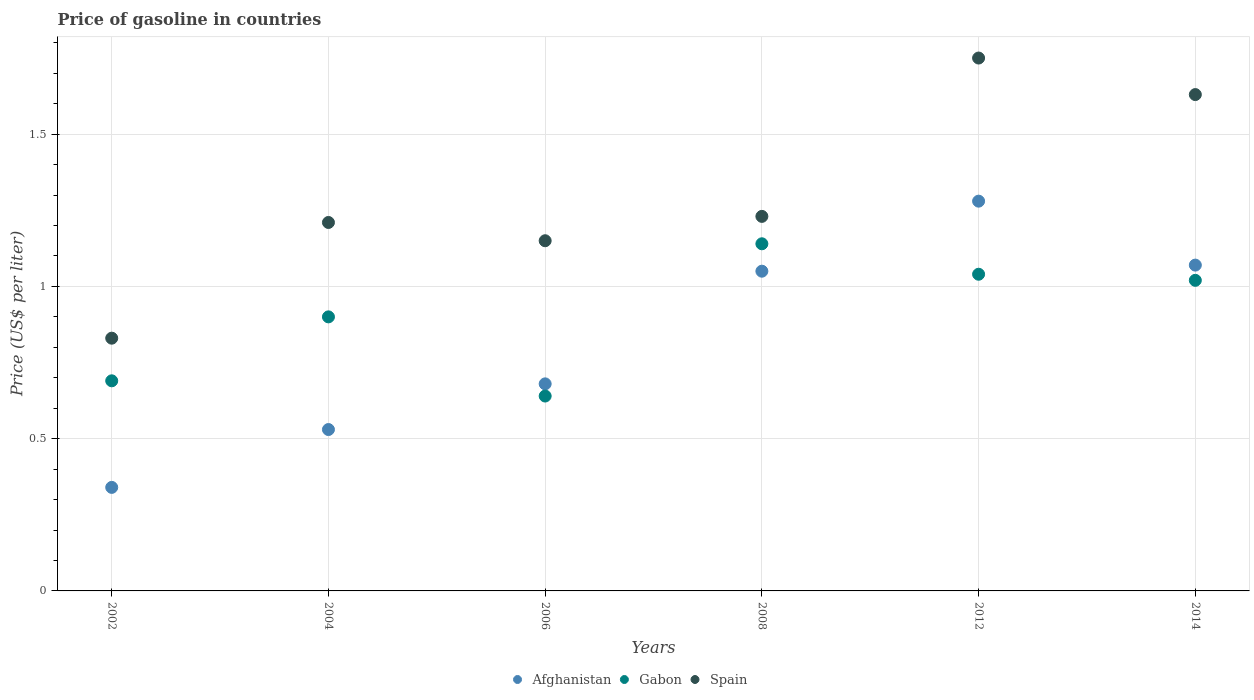What is the price of gasoline in Spain in 2014?
Give a very brief answer. 1.63. Across all years, what is the maximum price of gasoline in Spain?
Your answer should be very brief. 1.75. Across all years, what is the minimum price of gasoline in Afghanistan?
Your answer should be compact. 0.34. In which year was the price of gasoline in Spain minimum?
Your answer should be very brief. 2002. What is the total price of gasoline in Gabon in the graph?
Provide a short and direct response. 5.43. What is the difference between the price of gasoline in Spain in 2004 and that in 2014?
Your answer should be very brief. -0.42. What is the difference between the price of gasoline in Spain in 2002 and the price of gasoline in Afghanistan in 2008?
Make the answer very short. -0.22. What is the average price of gasoline in Gabon per year?
Give a very brief answer. 0.9. In the year 2004, what is the difference between the price of gasoline in Gabon and price of gasoline in Afghanistan?
Your answer should be compact. 0.37. In how many years, is the price of gasoline in Spain greater than 1.1 US$?
Your answer should be very brief. 5. What is the ratio of the price of gasoline in Afghanistan in 2006 to that in 2008?
Your answer should be compact. 0.65. Is the price of gasoline in Afghanistan in 2004 less than that in 2014?
Keep it short and to the point. Yes. What is the difference between the highest and the second highest price of gasoline in Spain?
Provide a succinct answer. 0.12. What is the difference between the highest and the lowest price of gasoline in Gabon?
Ensure brevity in your answer.  0.5. In how many years, is the price of gasoline in Spain greater than the average price of gasoline in Spain taken over all years?
Make the answer very short. 2. Is the price of gasoline in Spain strictly less than the price of gasoline in Afghanistan over the years?
Provide a short and direct response. No. Are the values on the major ticks of Y-axis written in scientific E-notation?
Ensure brevity in your answer.  No. Does the graph contain grids?
Offer a very short reply. Yes. Where does the legend appear in the graph?
Keep it short and to the point. Bottom center. How are the legend labels stacked?
Keep it short and to the point. Horizontal. What is the title of the graph?
Provide a short and direct response. Price of gasoline in countries. Does "Indonesia" appear as one of the legend labels in the graph?
Provide a succinct answer. No. What is the label or title of the X-axis?
Your answer should be compact. Years. What is the label or title of the Y-axis?
Keep it short and to the point. Price (US$ per liter). What is the Price (US$ per liter) of Afghanistan in 2002?
Your response must be concise. 0.34. What is the Price (US$ per liter) of Gabon in 2002?
Provide a short and direct response. 0.69. What is the Price (US$ per liter) of Spain in 2002?
Ensure brevity in your answer.  0.83. What is the Price (US$ per liter) of Afghanistan in 2004?
Offer a terse response. 0.53. What is the Price (US$ per liter) in Gabon in 2004?
Offer a very short reply. 0.9. What is the Price (US$ per liter) in Spain in 2004?
Provide a succinct answer. 1.21. What is the Price (US$ per liter) of Afghanistan in 2006?
Make the answer very short. 0.68. What is the Price (US$ per liter) in Gabon in 2006?
Provide a succinct answer. 0.64. What is the Price (US$ per liter) of Spain in 2006?
Ensure brevity in your answer.  1.15. What is the Price (US$ per liter) in Afghanistan in 2008?
Ensure brevity in your answer.  1.05. What is the Price (US$ per liter) of Gabon in 2008?
Make the answer very short. 1.14. What is the Price (US$ per liter) of Spain in 2008?
Provide a short and direct response. 1.23. What is the Price (US$ per liter) in Afghanistan in 2012?
Offer a terse response. 1.28. What is the Price (US$ per liter) in Afghanistan in 2014?
Your response must be concise. 1.07. What is the Price (US$ per liter) of Gabon in 2014?
Provide a succinct answer. 1.02. What is the Price (US$ per liter) in Spain in 2014?
Give a very brief answer. 1.63. Across all years, what is the maximum Price (US$ per liter) of Afghanistan?
Offer a terse response. 1.28. Across all years, what is the maximum Price (US$ per liter) of Gabon?
Offer a very short reply. 1.14. Across all years, what is the minimum Price (US$ per liter) in Afghanistan?
Keep it short and to the point. 0.34. Across all years, what is the minimum Price (US$ per liter) in Gabon?
Your answer should be very brief. 0.64. Across all years, what is the minimum Price (US$ per liter) of Spain?
Provide a short and direct response. 0.83. What is the total Price (US$ per liter) of Afghanistan in the graph?
Your response must be concise. 4.95. What is the total Price (US$ per liter) in Gabon in the graph?
Ensure brevity in your answer.  5.43. What is the total Price (US$ per liter) of Spain in the graph?
Keep it short and to the point. 7.8. What is the difference between the Price (US$ per liter) in Afghanistan in 2002 and that in 2004?
Your response must be concise. -0.19. What is the difference between the Price (US$ per liter) of Gabon in 2002 and that in 2004?
Your answer should be very brief. -0.21. What is the difference between the Price (US$ per liter) of Spain in 2002 and that in 2004?
Your response must be concise. -0.38. What is the difference between the Price (US$ per liter) of Afghanistan in 2002 and that in 2006?
Offer a very short reply. -0.34. What is the difference between the Price (US$ per liter) of Spain in 2002 and that in 2006?
Offer a very short reply. -0.32. What is the difference between the Price (US$ per liter) in Afghanistan in 2002 and that in 2008?
Provide a short and direct response. -0.71. What is the difference between the Price (US$ per liter) of Gabon in 2002 and that in 2008?
Provide a succinct answer. -0.45. What is the difference between the Price (US$ per liter) of Spain in 2002 and that in 2008?
Keep it short and to the point. -0.4. What is the difference between the Price (US$ per liter) in Afghanistan in 2002 and that in 2012?
Offer a terse response. -0.94. What is the difference between the Price (US$ per liter) of Gabon in 2002 and that in 2012?
Your response must be concise. -0.35. What is the difference between the Price (US$ per liter) in Spain in 2002 and that in 2012?
Ensure brevity in your answer.  -0.92. What is the difference between the Price (US$ per liter) of Afghanistan in 2002 and that in 2014?
Offer a terse response. -0.73. What is the difference between the Price (US$ per liter) in Gabon in 2002 and that in 2014?
Make the answer very short. -0.33. What is the difference between the Price (US$ per liter) in Spain in 2002 and that in 2014?
Give a very brief answer. -0.8. What is the difference between the Price (US$ per liter) in Gabon in 2004 and that in 2006?
Provide a short and direct response. 0.26. What is the difference between the Price (US$ per liter) of Spain in 2004 and that in 2006?
Offer a very short reply. 0.06. What is the difference between the Price (US$ per liter) of Afghanistan in 2004 and that in 2008?
Offer a terse response. -0.52. What is the difference between the Price (US$ per liter) in Gabon in 2004 and that in 2008?
Keep it short and to the point. -0.24. What is the difference between the Price (US$ per liter) of Spain in 2004 and that in 2008?
Ensure brevity in your answer.  -0.02. What is the difference between the Price (US$ per liter) of Afghanistan in 2004 and that in 2012?
Provide a succinct answer. -0.75. What is the difference between the Price (US$ per liter) of Gabon in 2004 and that in 2012?
Keep it short and to the point. -0.14. What is the difference between the Price (US$ per liter) of Spain in 2004 and that in 2012?
Provide a succinct answer. -0.54. What is the difference between the Price (US$ per liter) in Afghanistan in 2004 and that in 2014?
Offer a terse response. -0.54. What is the difference between the Price (US$ per liter) of Gabon in 2004 and that in 2014?
Your answer should be very brief. -0.12. What is the difference between the Price (US$ per liter) of Spain in 2004 and that in 2014?
Keep it short and to the point. -0.42. What is the difference between the Price (US$ per liter) in Afghanistan in 2006 and that in 2008?
Offer a very short reply. -0.37. What is the difference between the Price (US$ per liter) in Spain in 2006 and that in 2008?
Offer a terse response. -0.08. What is the difference between the Price (US$ per liter) in Gabon in 2006 and that in 2012?
Make the answer very short. -0.4. What is the difference between the Price (US$ per liter) in Spain in 2006 and that in 2012?
Make the answer very short. -0.6. What is the difference between the Price (US$ per liter) in Afghanistan in 2006 and that in 2014?
Make the answer very short. -0.39. What is the difference between the Price (US$ per liter) in Gabon in 2006 and that in 2014?
Your answer should be compact. -0.38. What is the difference between the Price (US$ per liter) of Spain in 2006 and that in 2014?
Give a very brief answer. -0.48. What is the difference between the Price (US$ per liter) in Afghanistan in 2008 and that in 2012?
Offer a very short reply. -0.23. What is the difference between the Price (US$ per liter) of Gabon in 2008 and that in 2012?
Your response must be concise. 0.1. What is the difference between the Price (US$ per liter) in Spain in 2008 and that in 2012?
Make the answer very short. -0.52. What is the difference between the Price (US$ per liter) in Afghanistan in 2008 and that in 2014?
Keep it short and to the point. -0.02. What is the difference between the Price (US$ per liter) in Gabon in 2008 and that in 2014?
Keep it short and to the point. 0.12. What is the difference between the Price (US$ per liter) in Spain in 2008 and that in 2014?
Make the answer very short. -0.4. What is the difference between the Price (US$ per liter) in Afghanistan in 2012 and that in 2014?
Your answer should be very brief. 0.21. What is the difference between the Price (US$ per liter) in Gabon in 2012 and that in 2014?
Provide a short and direct response. 0.02. What is the difference between the Price (US$ per liter) of Spain in 2012 and that in 2014?
Provide a short and direct response. 0.12. What is the difference between the Price (US$ per liter) in Afghanistan in 2002 and the Price (US$ per liter) in Gabon in 2004?
Your response must be concise. -0.56. What is the difference between the Price (US$ per liter) of Afghanistan in 2002 and the Price (US$ per liter) of Spain in 2004?
Keep it short and to the point. -0.87. What is the difference between the Price (US$ per liter) of Gabon in 2002 and the Price (US$ per liter) of Spain in 2004?
Provide a short and direct response. -0.52. What is the difference between the Price (US$ per liter) in Afghanistan in 2002 and the Price (US$ per liter) in Spain in 2006?
Provide a short and direct response. -0.81. What is the difference between the Price (US$ per liter) in Gabon in 2002 and the Price (US$ per liter) in Spain in 2006?
Provide a succinct answer. -0.46. What is the difference between the Price (US$ per liter) in Afghanistan in 2002 and the Price (US$ per liter) in Gabon in 2008?
Keep it short and to the point. -0.8. What is the difference between the Price (US$ per liter) in Afghanistan in 2002 and the Price (US$ per liter) in Spain in 2008?
Your answer should be very brief. -0.89. What is the difference between the Price (US$ per liter) in Gabon in 2002 and the Price (US$ per liter) in Spain in 2008?
Your response must be concise. -0.54. What is the difference between the Price (US$ per liter) of Afghanistan in 2002 and the Price (US$ per liter) of Spain in 2012?
Give a very brief answer. -1.41. What is the difference between the Price (US$ per liter) in Gabon in 2002 and the Price (US$ per liter) in Spain in 2012?
Offer a very short reply. -1.06. What is the difference between the Price (US$ per liter) of Afghanistan in 2002 and the Price (US$ per liter) of Gabon in 2014?
Your answer should be very brief. -0.68. What is the difference between the Price (US$ per liter) of Afghanistan in 2002 and the Price (US$ per liter) of Spain in 2014?
Keep it short and to the point. -1.29. What is the difference between the Price (US$ per liter) of Gabon in 2002 and the Price (US$ per liter) of Spain in 2014?
Make the answer very short. -0.94. What is the difference between the Price (US$ per liter) of Afghanistan in 2004 and the Price (US$ per liter) of Gabon in 2006?
Offer a terse response. -0.11. What is the difference between the Price (US$ per liter) in Afghanistan in 2004 and the Price (US$ per liter) in Spain in 2006?
Give a very brief answer. -0.62. What is the difference between the Price (US$ per liter) of Afghanistan in 2004 and the Price (US$ per liter) of Gabon in 2008?
Your answer should be very brief. -0.61. What is the difference between the Price (US$ per liter) in Afghanistan in 2004 and the Price (US$ per liter) in Spain in 2008?
Make the answer very short. -0.7. What is the difference between the Price (US$ per liter) of Gabon in 2004 and the Price (US$ per liter) of Spain in 2008?
Make the answer very short. -0.33. What is the difference between the Price (US$ per liter) of Afghanistan in 2004 and the Price (US$ per liter) of Gabon in 2012?
Make the answer very short. -0.51. What is the difference between the Price (US$ per liter) of Afghanistan in 2004 and the Price (US$ per liter) of Spain in 2012?
Make the answer very short. -1.22. What is the difference between the Price (US$ per liter) in Gabon in 2004 and the Price (US$ per liter) in Spain in 2012?
Your answer should be very brief. -0.85. What is the difference between the Price (US$ per liter) in Afghanistan in 2004 and the Price (US$ per liter) in Gabon in 2014?
Your answer should be compact. -0.49. What is the difference between the Price (US$ per liter) in Gabon in 2004 and the Price (US$ per liter) in Spain in 2014?
Ensure brevity in your answer.  -0.73. What is the difference between the Price (US$ per liter) in Afghanistan in 2006 and the Price (US$ per liter) in Gabon in 2008?
Provide a succinct answer. -0.46. What is the difference between the Price (US$ per liter) in Afghanistan in 2006 and the Price (US$ per liter) in Spain in 2008?
Keep it short and to the point. -0.55. What is the difference between the Price (US$ per liter) in Gabon in 2006 and the Price (US$ per liter) in Spain in 2008?
Offer a very short reply. -0.59. What is the difference between the Price (US$ per liter) in Afghanistan in 2006 and the Price (US$ per liter) in Gabon in 2012?
Ensure brevity in your answer.  -0.36. What is the difference between the Price (US$ per liter) in Afghanistan in 2006 and the Price (US$ per liter) in Spain in 2012?
Give a very brief answer. -1.07. What is the difference between the Price (US$ per liter) in Gabon in 2006 and the Price (US$ per liter) in Spain in 2012?
Give a very brief answer. -1.11. What is the difference between the Price (US$ per liter) in Afghanistan in 2006 and the Price (US$ per liter) in Gabon in 2014?
Provide a short and direct response. -0.34. What is the difference between the Price (US$ per liter) of Afghanistan in 2006 and the Price (US$ per liter) of Spain in 2014?
Your answer should be very brief. -0.95. What is the difference between the Price (US$ per liter) of Gabon in 2006 and the Price (US$ per liter) of Spain in 2014?
Ensure brevity in your answer.  -0.99. What is the difference between the Price (US$ per liter) in Afghanistan in 2008 and the Price (US$ per liter) in Gabon in 2012?
Offer a terse response. 0.01. What is the difference between the Price (US$ per liter) of Afghanistan in 2008 and the Price (US$ per liter) of Spain in 2012?
Your answer should be very brief. -0.7. What is the difference between the Price (US$ per liter) in Gabon in 2008 and the Price (US$ per liter) in Spain in 2012?
Give a very brief answer. -0.61. What is the difference between the Price (US$ per liter) of Afghanistan in 2008 and the Price (US$ per liter) of Spain in 2014?
Give a very brief answer. -0.58. What is the difference between the Price (US$ per liter) of Gabon in 2008 and the Price (US$ per liter) of Spain in 2014?
Provide a succinct answer. -0.49. What is the difference between the Price (US$ per liter) in Afghanistan in 2012 and the Price (US$ per liter) in Gabon in 2014?
Make the answer very short. 0.26. What is the difference between the Price (US$ per liter) of Afghanistan in 2012 and the Price (US$ per liter) of Spain in 2014?
Offer a terse response. -0.35. What is the difference between the Price (US$ per liter) of Gabon in 2012 and the Price (US$ per liter) of Spain in 2014?
Offer a terse response. -0.59. What is the average Price (US$ per liter) in Afghanistan per year?
Ensure brevity in your answer.  0.82. What is the average Price (US$ per liter) of Gabon per year?
Your answer should be compact. 0.91. What is the average Price (US$ per liter) in Spain per year?
Your response must be concise. 1.3. In the year 2002, what is the difference between the Price (US$ per liter) in Afghanistan and Price (US$ per liter) in Gabon?
Provide a succinct answer. -0.35. In the year 2002, what is the difference between the Price (US$ per liter) in Afghanistan and Price (US$ per liter) in Spain?
Ensure brevity in your answer.  -0.49. In the year 2002, what is the difference between the Price (US$ per liter) in Gabon and Price (US$ per liter) in Spain?
Your response must be concise. -0.14. In the year 2004, what is the difference between the Price (US$ per liter) of Afghanistan and Price (US$ per liter) of Gabon?
Give a very brief answer. -0.37. In the year 2004, what is the difference between the Price (US$ per liter) of Afghanistan and Price (US$ per liter) of Spain?
Your response must be concise. -0.68. In the year 2004, what is the difference between the Price (US$ per liter) of Gabon and Price (US$ per liter) of Spain?
Give a very brief answer. -0.31. In the year 2006, what is the difference between the Price (US$ per liter) in Afghanistan and Price (US$ per liter) in Gabon?
Offer a very short reply. 0.04. In the year 2006, what is the difference between the Price (US$ per liter) of Afghanistan and Price (US$ per liter) of Spain?
Keep it short and to the point. -0.47. In the year 2006, what is the difference between the Price (US$ per liter) of Gabon and Price (US$ per liter) of Spain?
Your answer should be compact. -0.51. In the year 2008, what is the difference between the Price (US$ per liter) of Afghanistan and Price (US$ per liter) of Gabon?
Offer a terse response. -0.09. In the year 2008, what is the difference between the Price (US$ per liter) of Afghanistan and Price (US$ per liter) of Spain?
Keep it short and to the point. -0.18. In the year 2008, what is the difference between the Price (US$ per liter) of Gabon and Price (US$ per liter) of Spain?
Your answer should be compact. -0.09. In the year 2012, what is the difference between the Price (US$ per liter) of Afghanistan and Price (US$ per liter) of Gabon?
Your answer should be very brief. 0.24. In the year 2012, what is the difference between the Price (US$ per liter) in Afghanistan and Price (US$ per liter) in Spain?
Provide a short and direct response. -0.47. In the year 2012, what is the difference between the Price (US$ per liter) in Gabon and Price (US$ per liter) in Spain?
Provide a succinct answer. -0.71. In the year 2014, what is the difference between the Price (US$ per liter) of Afghanistan and Price (US$ per liter) of Spain?
Ensure brevity in your answer.  -0.56. In the year 2014, what is the difference between the Price (US$ per liter) of Gabon and Price (US$ per liter) of Spain?
Your answer should be very brief. -0.61. What is the ratio of the Price (US$ per liter) in Afghanistan in 2002 to that in 2004?
Keep it short and to the point. 0.64. What is the ratio of the Price (US$ per liter) of Gabon in 2002 to that in 2004?
Keep it short and to the point. 0.77. What is the ratio of the Price (US$ per liter) of Spain in 2002 to that in 2004?
Your answer should be compact. 0.69. What is the ratio of the Price (US$ per liter) in Gabon in 2002 to that in 2006?
Provide a succinct answer. 1.08. What is the ratio of the Price (US$ per liter) of Spain in 2002 to that in 2006?
Make the answer very short. 0.72. What is the ratio of the Price (US$ per liter) in Afghanistan in 2002 to that in 2008?
Provide a short and direct response. 0.32. What is the ratio of the Price (US$ per liter) in Gabon in 2002 to that in 2008?
Provide a succinct answer. 0.61. What is the ratio of the Price (US$ per liter) of Spain in 2002 to that in 2008?
Keep it short and to the point. 0.67. What is the ratio of the Price (US$ per liter) of Afghanistan in 2002 to that in 2012?
Your answer should be very brief. 0.27. What is the ratio of the Price (US$ per liter) of Gabon in 2002 to that in 2012?
Your answer should be compact. 0.66. What is the ratio of the Price (US$ per liter) of Spain in 2002 to that in 2012?
Offer a very short reply. 0.47. What is the ratio of the Price (US$ per liter) in Afghanistan in 2002 to that in 2014?
Make the answer very short. 0.32. What is the ratio of the Price (US$ per liter) in Gabon in 2002 to that in 2014?
Provide a succinct answer. 0.68. What is the ratio of the Price (US$ per liter) of Spain in 2002 to that in 2014?
Give a very brief answer. 0.51. What is the ratio of the Price (US$ per liter) in Afghanistan in 2004 to that in 2006?
Provide a short and direct response. 0.78. What is the ratio of the Price (US$ per liter) in Gabon in 2004 to that in 2006?
Your answer should be very brief. 1.41. What is the ratio of the Price (US$ per liter) of Spain in 2004 to that in 2006?
Ensure brevity in your answer.  1.05. What is the ratio of the Price (US$ per liter) in Afghanistan in 2004 to that in 2008?
Offer a very short reply. 0.5. What is the ratio of the Price (US$ per liter) of Gabon in 2004 to that in 2008?
Your answer should be compact. 0.79. What is the ratio of the Price (US$ per liter) in Spain in 2004 to that in 2008?
Offer a terse response. 0.98. What is the ratio of the Price (US$ per liter) of Afghanistan in 2004 to that in 2012?
Keep it short and to the point. 0.41. What is the ratio of the Price (US$ per liter) in Gabon in 2004 to that in 2012?
Your answer should be compact. 0.87. What is the ratio of the Price (US$ per liter) in Spain in 2004 to that in 2012?
Offer a terse response. 0.69. What is the ratio of the Price (US$ per liter) of Afghanistan in 2004 to that in 2014?
Offer a very short reply. 0.5. What is the ratio of the Price (US$ per liter) in Gabon in 2004 to that in 2014?
Your answer should be compact. 0.88. What is the ratio of the Price (US$ per liter) of Spain in 2004 to that in 2014?
Make the answer very short. 0.74. What is the ratio of the Price (US$ per liter) in Afghanistan in 2006 to that in 2008?
Give a very brief answer. 0.65. What is the ratio of the Price (US$ per liter) in Gabon in 2006 to that in 2008?
Your response must be concise. 0.56. What is the ratio of the Price (US$ per liter) of Spain in 2006 to that in 2008?
Make the answer very short. 0.94. What is the ratio of the Price (US$ per liter) of Afghanistan in 2006 to that in 2012?
Give a very brief answer. 0.53. What is the ratio of the Price (US$ per liter) in Gabon in 2006 to that in 2012?
Your response must be concise. 0.62. What is the ratio of the Price (US$ per liter) of Spain in 2006 to that in 2012?
Provide a succinct answer. 0.66. What is the ratio of the Price (US$ per liter) in Afghanistan in 2006 to that in 2014?
Give a very brief answer. 0.64. What is the ratio of the Price (US$ per liter) in Gabon in 2006 to that in 2014?
Provide a succinct answer. 0.63. What is the ratio of the Price (US$ per liter) in Spain in 2006 to that in 2014?
Make the answer very short. 0.71. What is the ratio of the Price (US$ per liter) of Afghanistan in 2008 to that in 2012?
Keep it short and to the point. 0.82. What is the ratio of the Price (US$ per liter) of Gabon in 2008 to that in 2012?
Ensure brevity in your answer.  1.1. What is the ratio of the Price (US$ per liter) of Spain in 2008 to that in 2012?
Offer a very short reply. 0.7. What is the ratio of the Price (US$ per liter) of Afghanistan in 2008 to that in 2014?
Provide a short and direct response. 0.98. What is the ratio of the Price (US$ per liter) in Gabon in 2008 to that in 2014?
Keep it short and to the point. 1.12. What is the ratio of the Price (US$ per liter) of Spain in 2008 to that in 2014?
Offer a very short reply. 0.75. What is the ratio of the Price (US$ per liter) of Afghanistan in 2012 to that in 2014?
Offer a very short reply. 1.2. What is the ratio of the Price (US$ per liter) in Gabon in 2012 to that in 2014?
Provide a short and direct response. 1.02. What is the ratio of the Price (US$ per liter) of Spain in 2012 to that in 2014?
Provide a succinct answer. 1.07. What is the difference between the highest and the second highest Price (US$ per liter) in Afghanistan?
Ensure brevity in your answer.  0.21. What is the difference between the highest and the second highest Price (US$ per liter) of Gabon?
Your answer should be very brief. 0.1. What is the difference between the highest and the second highest Price (US$ per liter) in Spain?
Give a very brief answer. 0.12. What is the difference between the highest and the lowest Price (US$ per liter) of Afghanistan?
Give a very brief answer. 0.94. What is the difference between the highest and the lowest Price (US$ per liter) in Spain?
Offer a terse response. 0.92. 